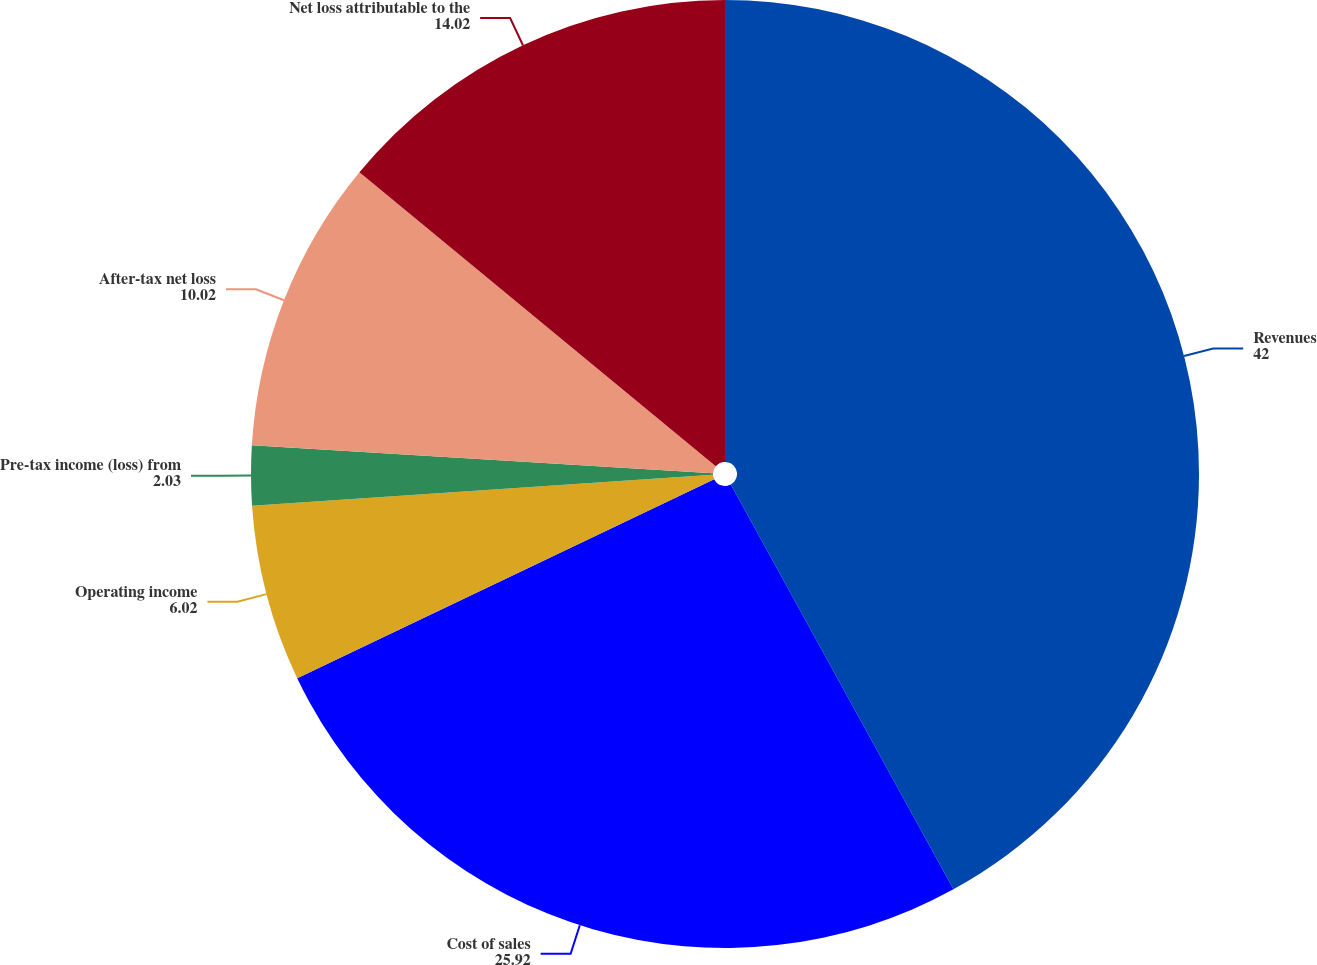Convert chart. <chart><loc_0><loc_0><loc_500><loc_500><pie_chart><fcel>Revenues<fcel>Cost of sales<fcel>Operating income<fcel>Pre-tax income (loss) from<fcel>After-tax net loss<fcel>Net loss attributable to the<nl><fcel>42.0%<fcel>25.92%<fcel>6.02%<fcel>2.03%<fcel>10.02%<fcel>14.02%<nl></chart> 